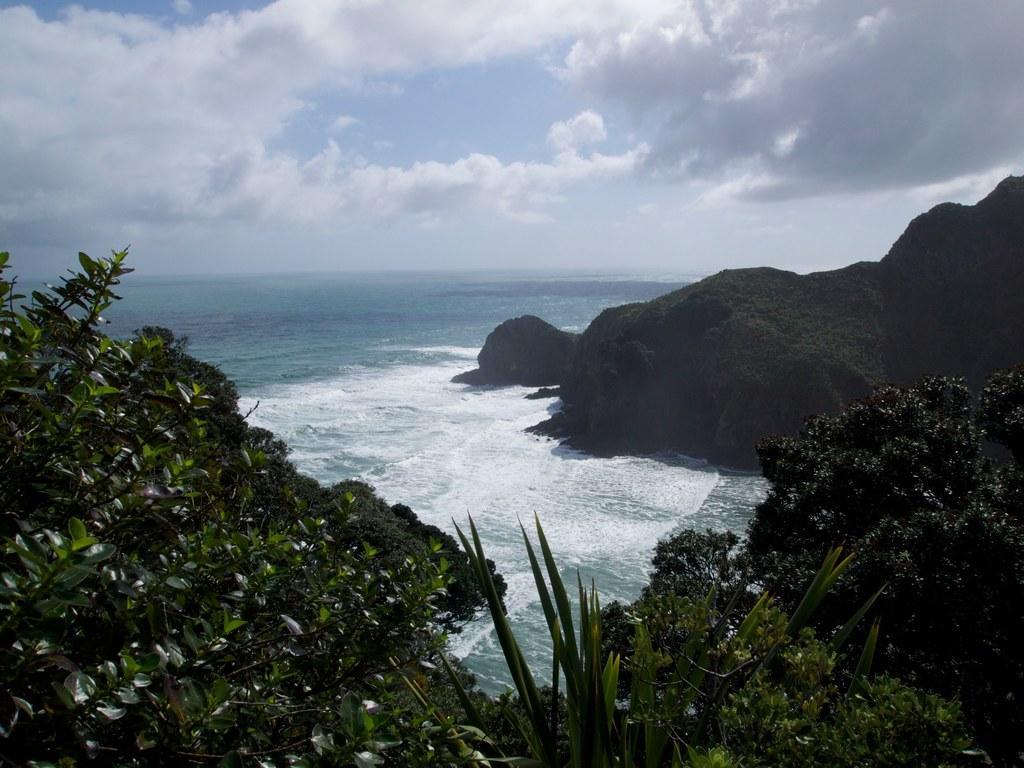Describe this image in one or two sentences. In this picture we can see water and few trees, in the background we can see clouds. 